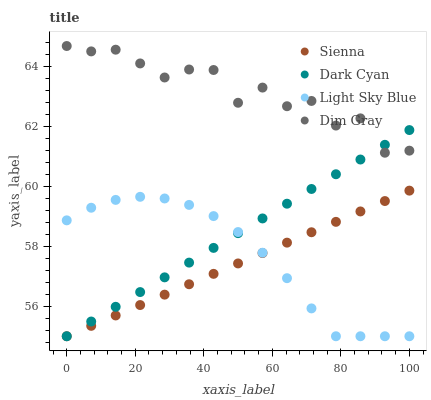Does Sienna have the minimum area under the curve?
Answer yes or no. Yes. Does Dim Gray have the maximum area under the curve?
Answer yes or no. Yes. Does Dark Cyan have the minimum area under the curve?
Answer yes or no. No. Does Dark Cyan have the maximum area under the curve?
Answer yes or no. No. Is Dark Cyan the smoothest?
Answer yes or no. Yes. Is Dim Gray the roughest?
Answer yes or no. Yes. Is Dim Gray the smoothest?
Answer yes or no. No. Is Dark Cyan the roughest?
Answer yes or no. No. Does Sienna have the lowest value?
Answer yes or no. Yes. Does Dim Gray have the lowest value?
Answer yes or no. No. Does Dim Gray have the highest value?
Answer yes or no. Yes. Does Dark Cyan have the highest value?
Answer yes or no. No. Is Sienna less than Dim Gray?
Answer yes or no. Yes. Is Dim Gray greater than Sienna?
Answer yes or no. Yes. Does Dark Cyan intersect Dim Gray?
Answer yes or no. Yes. Is Dark Cyan less than Dim Gray?
Answer yes or no. No. Is Dark Cyan greater than Dim Gray?
Answer yes or no. No. Does Sienna intersect Dim Gray?
Answer yes or no. No. 